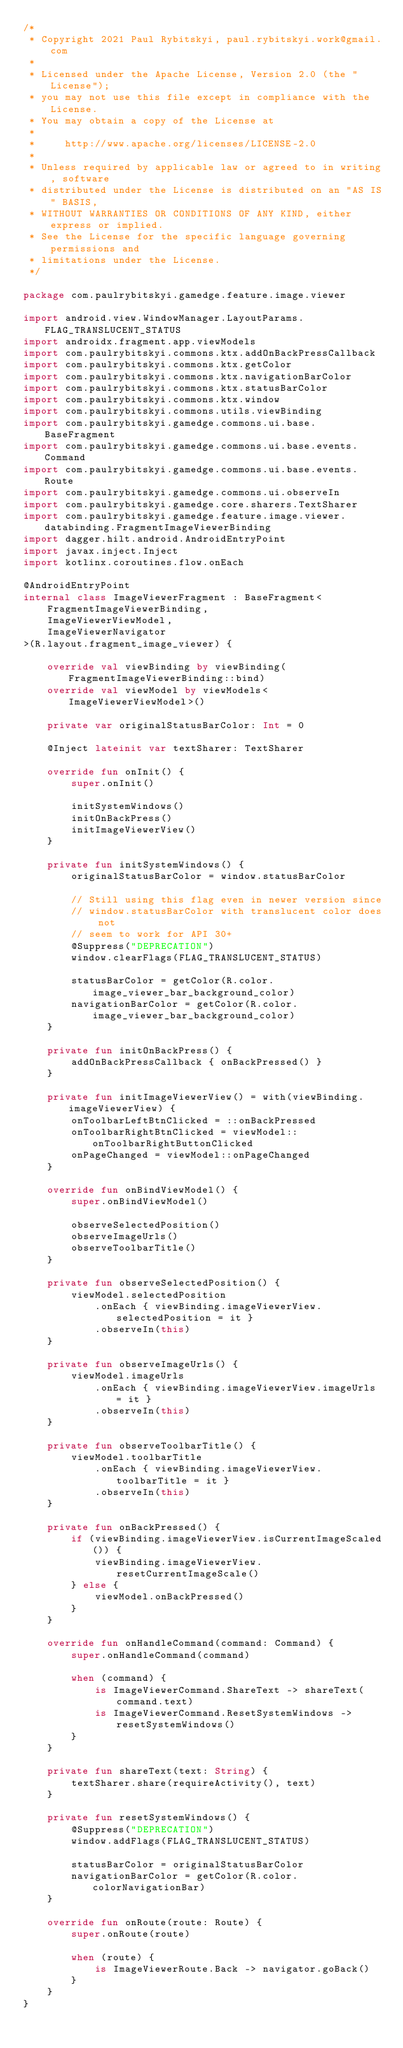Convert code to text. <code><loc_0><loc_0><loc_500><loc_500><_Kotlin_>/*
 * Copyright 2021 Paul Rybitskyi, paul.rybitskyi.work@gmail.com
 *
 * Licensed under the Apache License, Version 2.0 (the "License");
 * you may not use this file except in compliance with the License.
 * You may obtain a copy of the License at
 *
 *     http://www.apache.org/licenses/LICENSE-2.0
 *
 * Unless required by applicable law or agreed to in writing, software
 * distributed under the License is distributed on an "AS IS" BASIS,
 * WITHOUT WARRANTIES OR CONDITIONS OF ANY KIND, either express or implied.
 * See the License for the specific language governing permissions and
 * limitations under the License.
 */

package com.paulrybitskyi.gamedge.feature.image.viewer

import android.view.WindowManager.LayoutParams.FLAG_TRANSLUCENT_STATUS
import androidx.fragment.app.viewModels
import com.paulrybitskyi.commons.ktx.addOnBackPressCallback
import com.paulrybitskyi.commons.ktx.getColor
import com.paulrybitskyi.commons.ktx.navigationBarColor
import com.paulrybitskyi.commons.ktx.statusBarColor
import com.paulrybitskyi.commons.ktx.window
import com.paulrybitskyi.commons.utils.viewBinding
import com.paulrybitskyi.gamedge.commons.ui.base.BaseFragment
import com.paulrybitskyi.gamedge.commons.ui.base.events.Command
import com.paulrybitskyi.gamedge.commons.ui.base.events.Route
import com.paulrybitskyi.gamedge.commons.ui.observeIn
import com.paulrybitskyi.gamedge.core.sharers.TextSharer
import com.paulrybitskyi.gamedge.feature.image.viewer.databinding.FragmentImageViewerBinding
import dagger.hilt.android.AndroidEntryPoint
import javax.inject.Inject
import kotlinx.coroutines.flow.onEach

@AndroidEntryPoint
internal class ImageViewerFragment : BaseFragment<
    FragmentImageViewerBinding,
    ImageViewerViewModel,
    ImageViewerNavigator
>(R.layout.fragment_image_viewer) {

    override val viewBinding by viewBinding(FragmentImageViewerBinding::bind)
    override val viewModel by viewModels<ImageViewerViewModel>()

    private var originalStatusBarColor: Int = 0

    @Inject lateinit var textSharer: TextSharer

    override fun onInit() {
        super.onInit()

        initSystemWindows()
        initOnBackPress()
        initImageViewerView()
    }

    private fun initSystemWindows() {
        originalStatusBarColor = window.statusBarColor

        // Still using this flag even in newer version since
        // window.statusBarColor with translucent color does not
        // seem to work for API 30+
        @Suppress("DEPRECATION")
        window.clearFlags(FLAG_TRANSLUCENT_STATUS)

        statusBarColor = getColor(R.color.image_viewer_bar_background_color)
        navigationBarColor = getColor(R.color.image_viewer_bar_background_color)
    }

    private fun initOnBackPress() {
        addOnBackPressCallback { onBackPressed() }
    }

    private fun initImageViewerView() = with(viewBinding.imageViewerView) {
        onToolbarLeftBtnClicked = ::onBackPressed
        onToolbarRightBtnClicked = viewModel::onToolbarRightButtonClicked
        onPageChanged = viewModel::onPageChanged
    }

    override fun onBindViewModel() {
        super.onBindViewModel()

        observeSelectedPosition()
        observeImageUrls()
        observeToolbarTitle()
    }

    private fun observeSelectedPosition() {
        viewModel.selectedPosition
            .onEach { viewBinding.imageViewerView.selectedPosition = it }
            .observeIn(this)
    }

    private fun observeImageUrls() {
        viewModel.imageUrls
            .onEach { viewBinding.imageViewerView.imageUrls = it }
            .observeIn(this)
    }

    private fun observeToolbarTitle() {
        viewModel.toolbarTitle
            .onEach { viewBinding.imageViewerView.toolbarTitle = it }
            .observeIn(this)
    }

    private fun onBackPressed() {
        if (viewBinding.imageViewerView.isCurrentImageScaled()) {
            viewBinding.imageViewerView.resetCurrentImageScale()
        } else {
            viewModel.onBackPressed()
        }
    }

    override fun onHandleCommand(command: Command) {
        super.onHandleCommand(command)

        when (command) {
            is ImageViewerCommand.ShareText -> shareText(command.text)
            is ImageViewerCommand.ResetSystemWindows -> resetSystemWindows()
        }
    }

    private fun shareText(text: String) {
        textSharer.share(requireActivity(), text)
    }

    private fun resetSystemWindows() {
        @Suppress("DEPRECATION")
        window.addFlags(FLAG_TRANSLUCENT_STATUS)

        statusBarColor = originalStatusBarColor
        navigationBarColor = getColor(R.color.colorNavigationBar)
    }

    override fun onRoute(route: Route) {
        super.onRoute(route)

        when (route) {
            is ImageViewerRoute.Back -> navigator.goBack()
        }
    }
}
</code> 